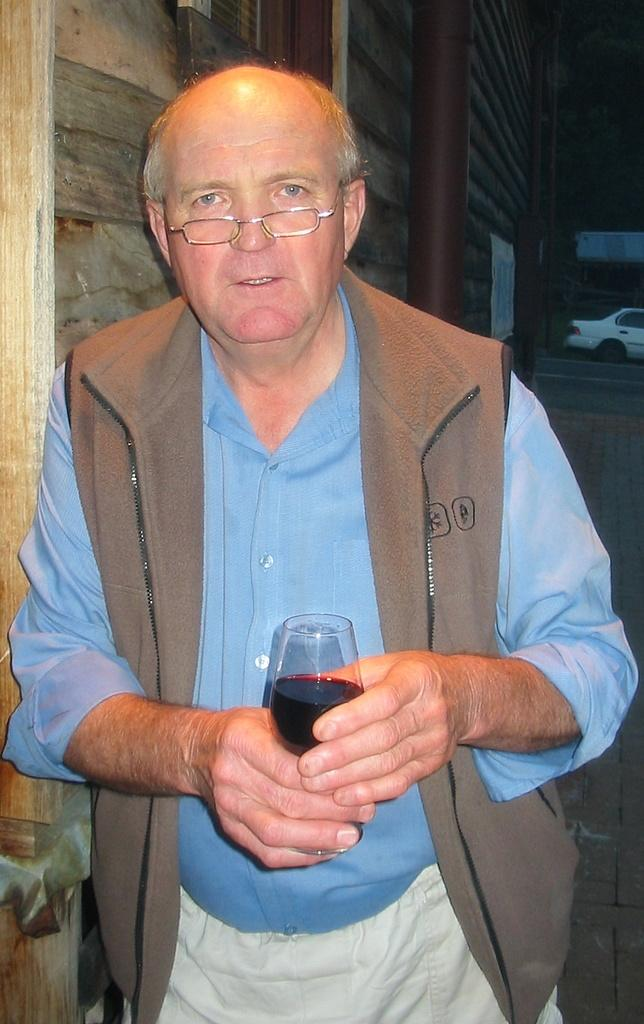What is the man in the image doing? The man is standing in the image and holding a glass. What is in the glass that the man is holding? The glass contains a black color liquid. What can be seen in the background of the image? There is a white color car in the background of the image. What is the color of the pole in the image? The pole in the image is brown color. What is the man's belief about the limit of the trick he is performing in the image? There is no trick being performed in the image, and therefore no belief about its limit can be determined. 